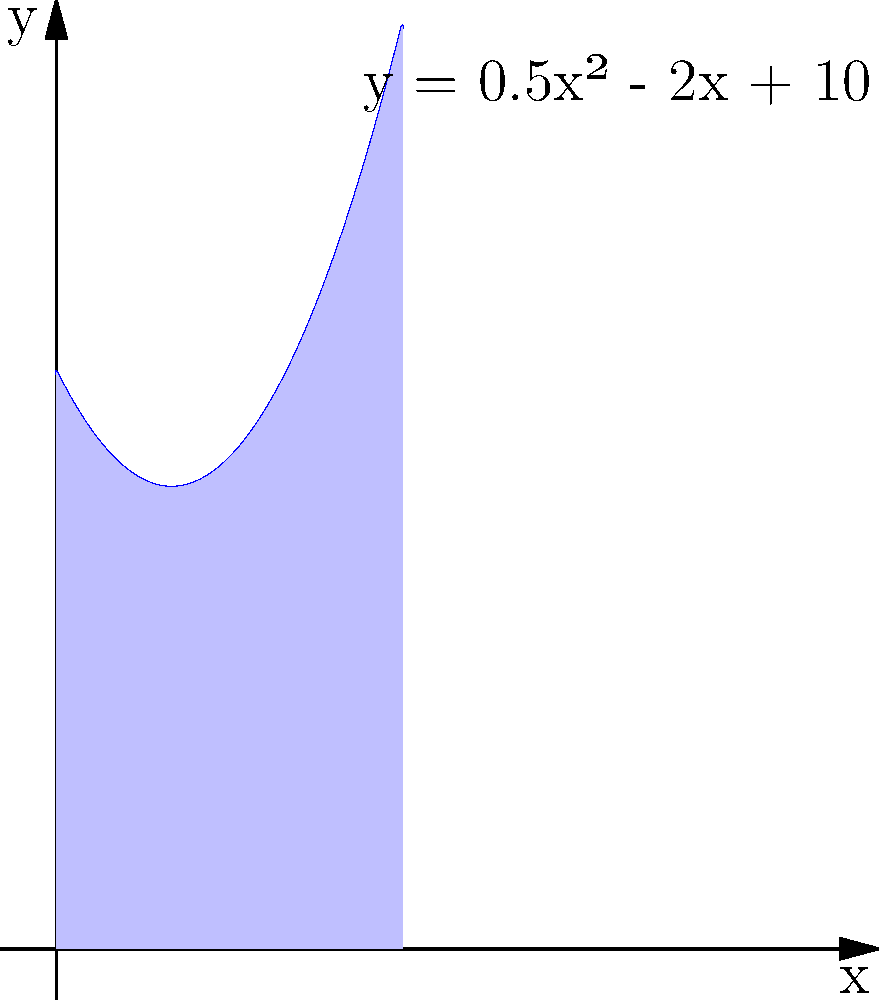As a baseball coach, you're designing a new junior league field. The outfield fence follows a curve described by the function $y = 0.5x^2 - 2x + 10$, where $x$ and $y$ are measured in tens of meters. If the field extends from $x = 0$ to $x = 6$, what is the area of the outfield in square meters? To find the area under the curve, we need to integrate the function from $x = 0$ to $x = 6$:

1) The integral is: $$\int_0^6 (0.5x^2 - 2x + 10) dx$$

2) Integrate each term:
   $$\left[\frac{1}{6}x^3 - x^2 + 10x\right]_0^6$$

3) Evaluate at the upper and lower bounds:
   $$\left(\frac{1}{6}(6^3) - 6^2 + 10(6)\right) - \left(\frac{1}{6}(0^3) - 0^2 + 10(0)\right)$$

4) Simplify:
   $$(36 - 36 + 60) - (0 - 0 + 0) = 60$$

5) The result is in units of 100 square meters (since $x$ and $y$ were in tens of meters).

6) Convert to square meters:
   $60 \times 100 = 6000$ square meters
Answer: 6000 square meters 